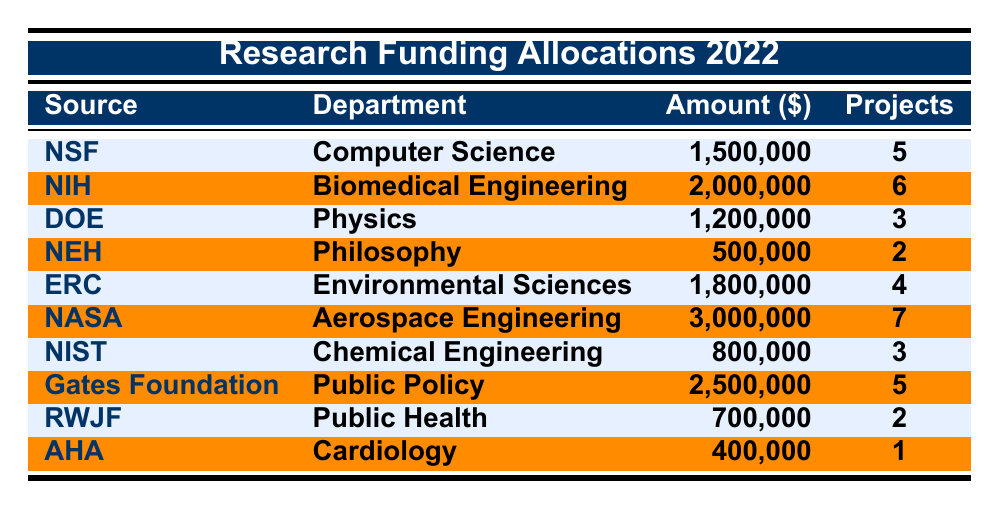What is the total amount allocated for research funding from NIH? According to the table, the amount allocated from NIH is listed as 2,000,000.
Answer: 2,000,000 Which department received the highest amount of funding? The department with the highest funding is Aerospace Engineering, which received 3,000,000 from NASA.
Answer: Aerospace Engineering How many projects are funded by the Bill & Melinda Gates Foundation? The table shows that the Bill & Melinda Gates Foundation funded 5 projects in the Department of Public Policy.
Answer: 5 What is the total amount allocated for the Department of Computer Science? The Department of Computer Science received an allocation of 1,500,000 from NSF.
Answer: 1,500,000 Which funding source allocated the least amount of money? The smallest funding source allocation is from the American Heart Association, which allocated 400,000.
Answer: American Heart Association What is the average amount allocated across all departments? The total funding allocated is 1500000 + 2000000 + 1200000 + 500000 + 1800000 + 3000000 + 800000 + 2500000 + 700000 + 400000 = 11600000. Dividing by the number of departments (10) gives an average of 1160000.
Answer: 1,160,000 Did the Department of Cardiology receive more funding than the Department of Philosophy? The Department of Cardiology received 400,000 while the Department of Philosophy received 500,000, so Cardiology received less funding.
Answer: No What is the total number of projects funded by all departments listed? Summing the number of projects for each department gives 5 + 6 + 3 + 2 + 4 + 7 + 3 + 5 + 2 + 1 = 38.
Answer: 38 Which department received funding from the European Research Council? The Department of Environmental Sciences received funding from the European Research Council, as indicated in the table.
Answer: Environmental Sciences Is the amount allocated to the Department of Chemical Engineering greater than the average allocation? The Department of Chemical Engineering received 800,000 and the average allocation is 1,160,000, hence it's less than the average.
Answer: No 